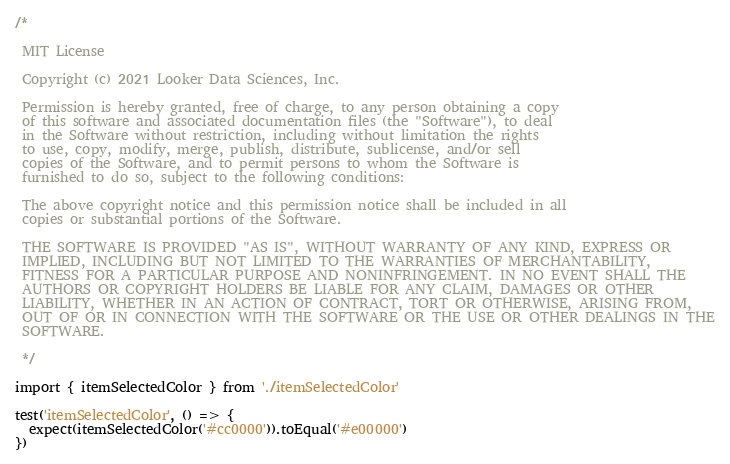<code> <loc_0><loc_0><loc_500><loc_500><_TypeScript_>/*

 MIT License

 Copyright (c) 2021 Looker Data Sciences, Inc.

 Permission is hereby granted, free of charge, to any person obtaining a copy
 of this software and associated documentation files (the "Software"), to deal
 in the Software without restriction, including without limitation the rights
 to use, copy, modify, merge, publish, distribute, sublicense, and/or sell
 copies of the Software, and to permit persons to whom the Software is
 furnished to do so, subject to the following conditions:

 The above copyright notice and this permission notice shall be included in all
 copies or substantial portions of the Software.

 THE SOFTWARE IS PROVIDED "AS IS", WITHOUT WARRANTY OF ANY KIND, EXPRESS OR
 IMPLIED, INCLUDING BUT NOT LIMITED TO THE WARRANTIES OF MERCHANTABILITY,
 FITNESS FOR A PARTICULAR PURPOSE AND NONINFRINGEMENT. IN NO EVENT SHALL THE
 AUTHORS OR COPYRIGHT HOLDERS BE LIABLE FOR ANY CLAIM, DAMAGES OR OTHER
 LIABILITY, WHETHER IN AN ACTION OF CONTRACT, TORT OR OTHERWISE, ARISING FROM,
 OUT OF OR IN CONNECTION WITH THE SOFTWARE OR THE USE OR OTHER DEALINGS IN THE
 SOFTWARE.

 */

import { itemSelectedColor } from './itemSelectedColor'

test('itemSelectedColor', () => {
  expect(itemSelectedColor('#cc0000')).toEqual('#e00000')
})
</code> 